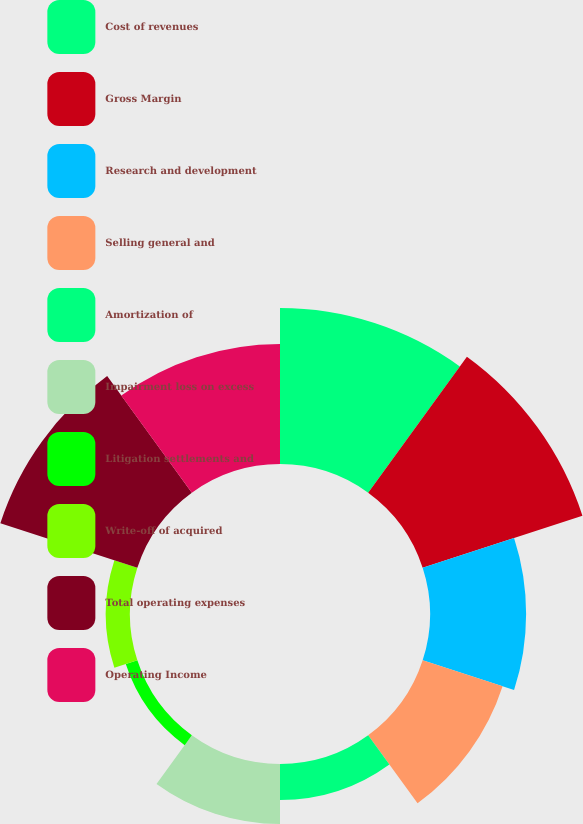<chart> <loc_0><loc_0><loc_500><loc_500><pie_chart><fcel>Cost of revenues<fcel>Gross Margin<fcel>Research and development<fcel>Selling general and<fcel>Amortization of<fcel>Impairment loss on excess<fcel>Litigation settlements and<fcel>Write-off of acquired<fcel>Total operating expenses<fcel>Operating Income<nl><fcel>17.32%<fcel>18.65%<fcel>10.67%<fcel>9.33%<fcel>4.01%<fcel>6.67%<fcel>1.35%<fcel>2.68%<fcel>15.99%<fcel>13.33%<nl></chart> 